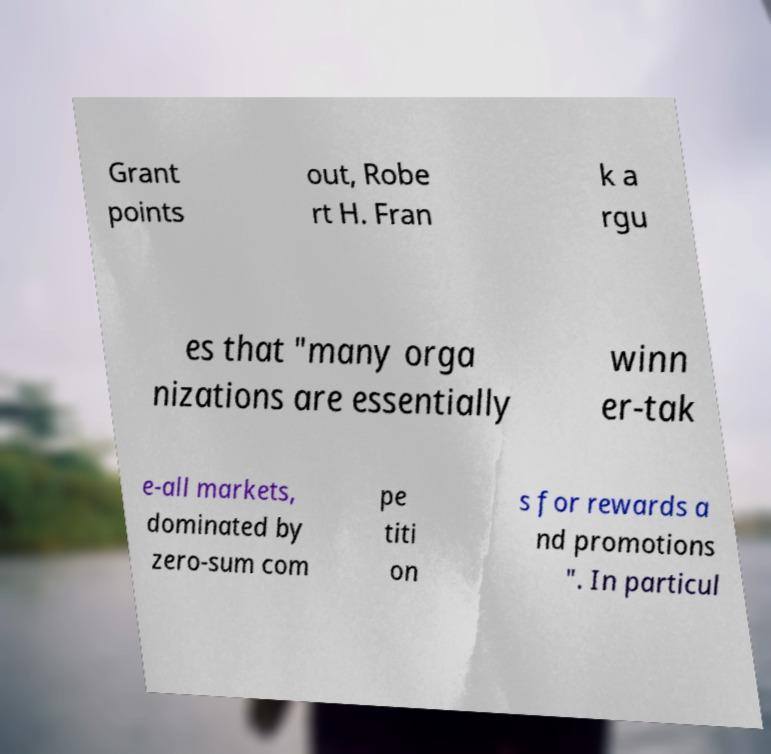Can you accurately transcribe the text from the provided image for me? Grant points out, Robe rt H. Fran k a rgu es that "many orga nizations are essentially winn er-tak e-all markets, dominated by zero-sum com pe titi on s for rewards a nd promotions ". In particul 